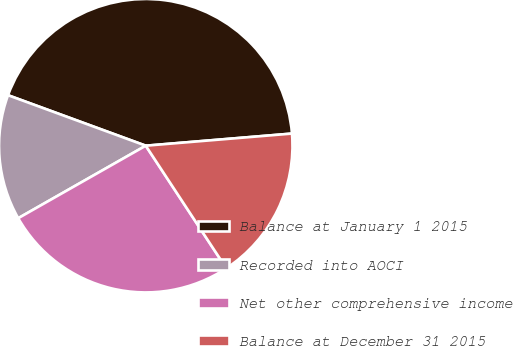Convert chart to OTSL. <chart><loc_0><loc_0><loc_500><loc_500><pie_chart><fcel>Balance at January 1 2015<fcel>Recorded into AOCI<fcel>Net other comprehensive income<fcel>Balance at December 31 2015<nl><fcel>43.09%<fcel>13.82%<fcel>26.02%<fcel>17.07%<nl></chart> 